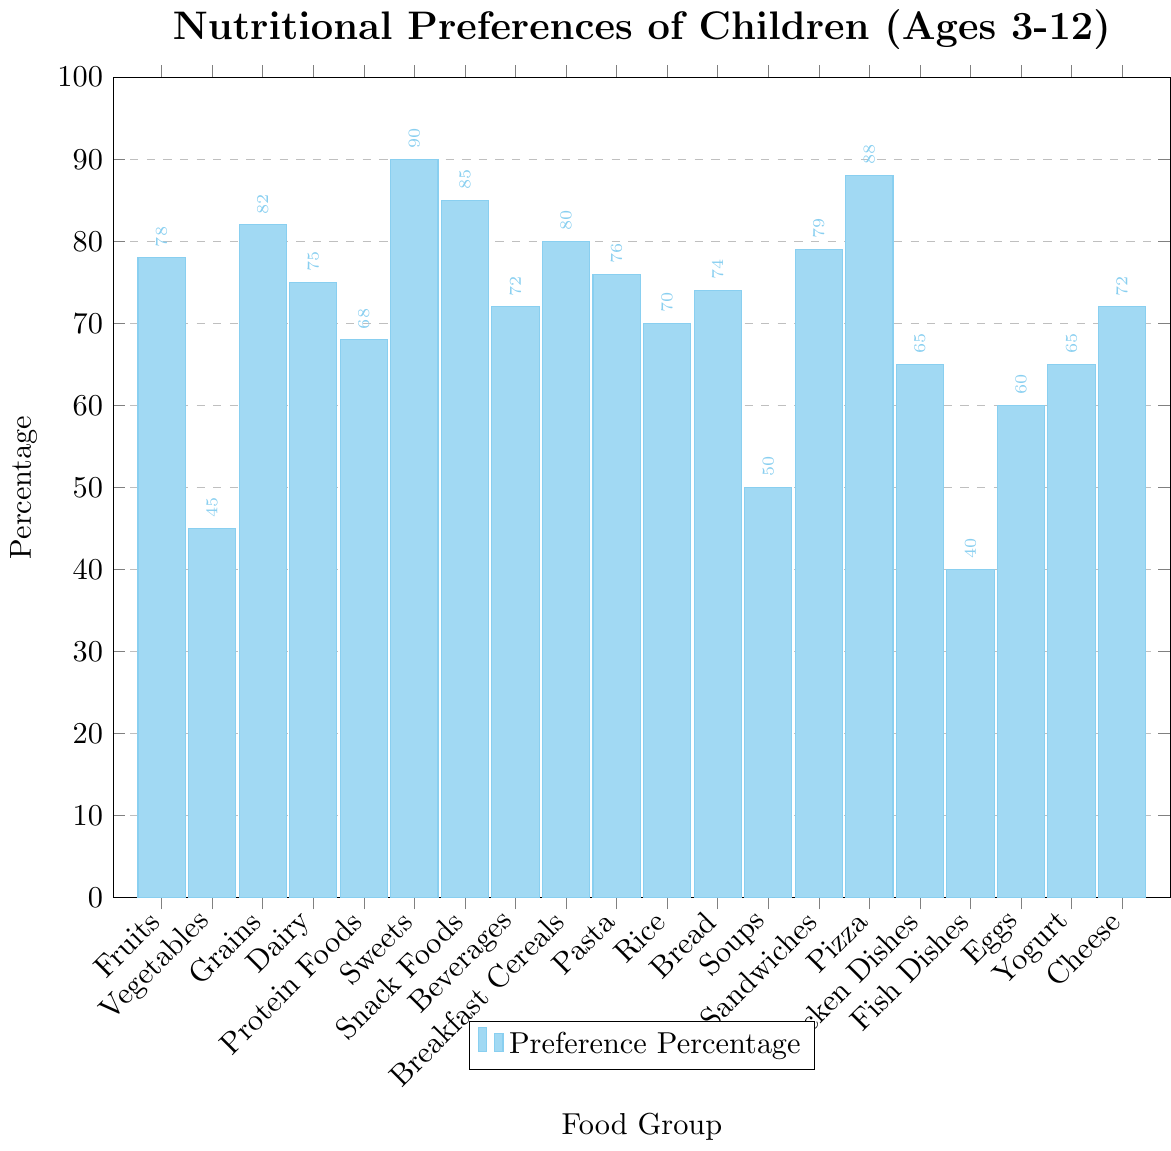Which food group has the highest nutritional preference percentage among children aged 3-12? The food group with the tallest bar has the highest preference percentage. Sweets have the tallest bar, indicating they have the highest preference percentage.
Answer: Sweets Which food group has the lowest nutritional preference percentage among children aged 3-12? The food group with the shortest bar has the lowest preference percentage. Fish Dishes have the shortest bar, indicating they have the lowest preference percentage.
Answer: Fish Dishes What is the combined preference percentage of Fruits and Vegetables? The preference percentage for Fruits is 78, and for Vegetables, it is 45. Adding these together: 78 + 45 = 123.
Answer: 123 Is the preference percentage for Grains higher or lower than that for Dairy? The height of the bar for Grains (82) is taller than the bar for Dairy (75), indicating that the preference percentage for Grains is higher.
Answer: Higher How does the preference percentage for Pizza compare to that for Chicken Dishes? The bar for Pizza is taller than the bar for Chicken Dishes. Pizza has a preference percentage of 88, whereas Chicken Dishes have 65. Thus, Pizza has a higher preference percentage.
Answer: Pizza has a higher preference percentage Which food groups have a preference percentage between 70 and 80? By examining the height of the bars, the preference percentages within this range are Beverages (72), Pasta (76), Rice (70), Bread (74), and Sandwiches (79).
Answer: Beverages, Pasta, Rice, Bread, Sandwiches Which food group has a preference percentage of 60%? By examining the figure, the food group with a bar height corresponding to 60% is Eggs.
Answer: Eggs What is the difference in preference percentages between the most preferred and least preferred food groups? The most preferred food group is Sweets (90), and the least preferred is Fish Dishes (40). The difference is 90 - 40 = 50.
Answer: 50 What are the names of the food groups with preference percentages above 80%? By analyzing the figure, the food groups with bars higher than 80% are Grains (82), Sweets (90), Snack Foods (85), Breakfast Cereals (80), and Pizza (88).
Answer: Grains, Sweets, Snack Foods, Breakfast Cereals, Pizza 